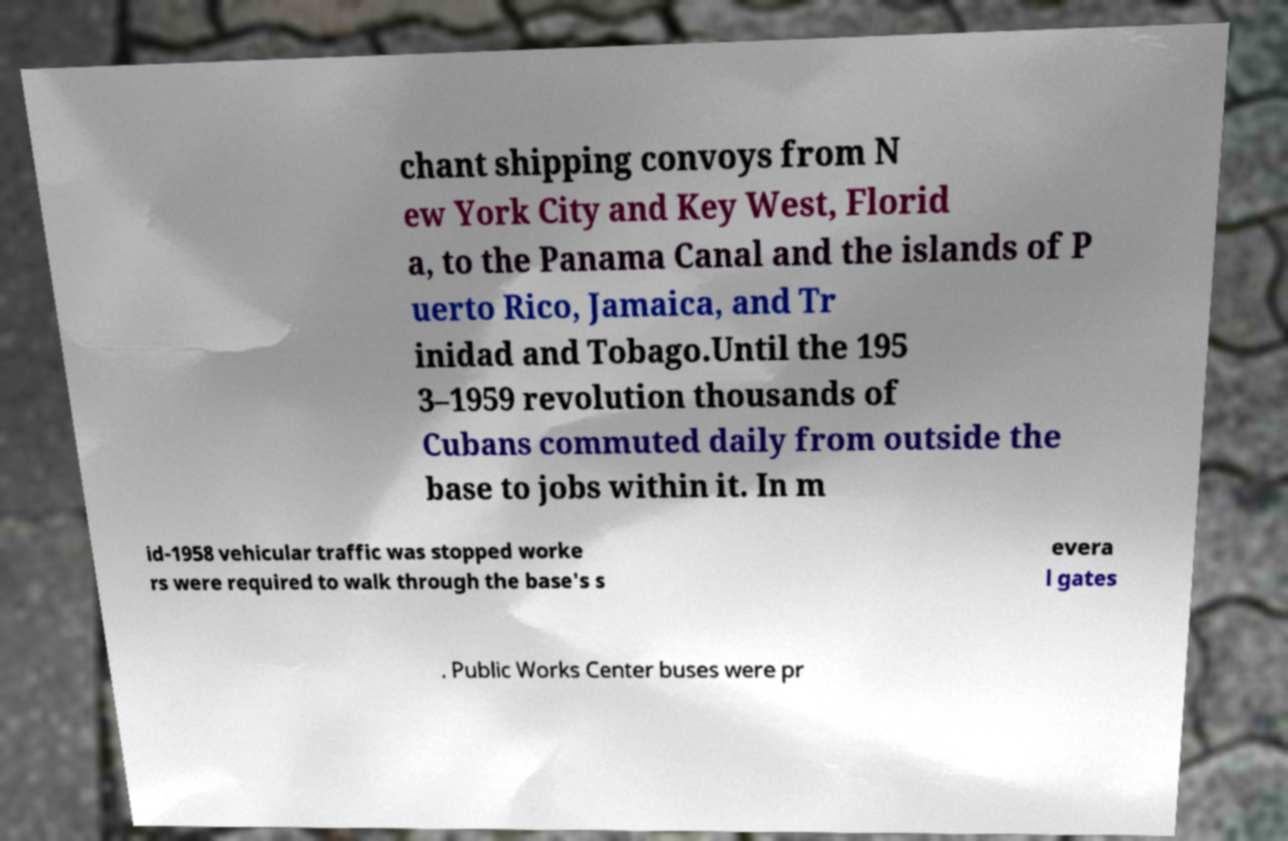What messages or text are displayed in this image? I need them in a readable, typed format. chant shipping convoys from N ew York City and Key West, Florid a, to the Panama Canal and the islands of P uerto Rico, Jamaica, and Tr inidad and Tobago.Until the 195 3–1959 revolution thousands of Cubans commuted daily from outside the base to jobs within it. In m id-1958 vehicular traffic was stopped worke rs were required to walk through the base's s evera l gates . Public Works Center buses were pr 